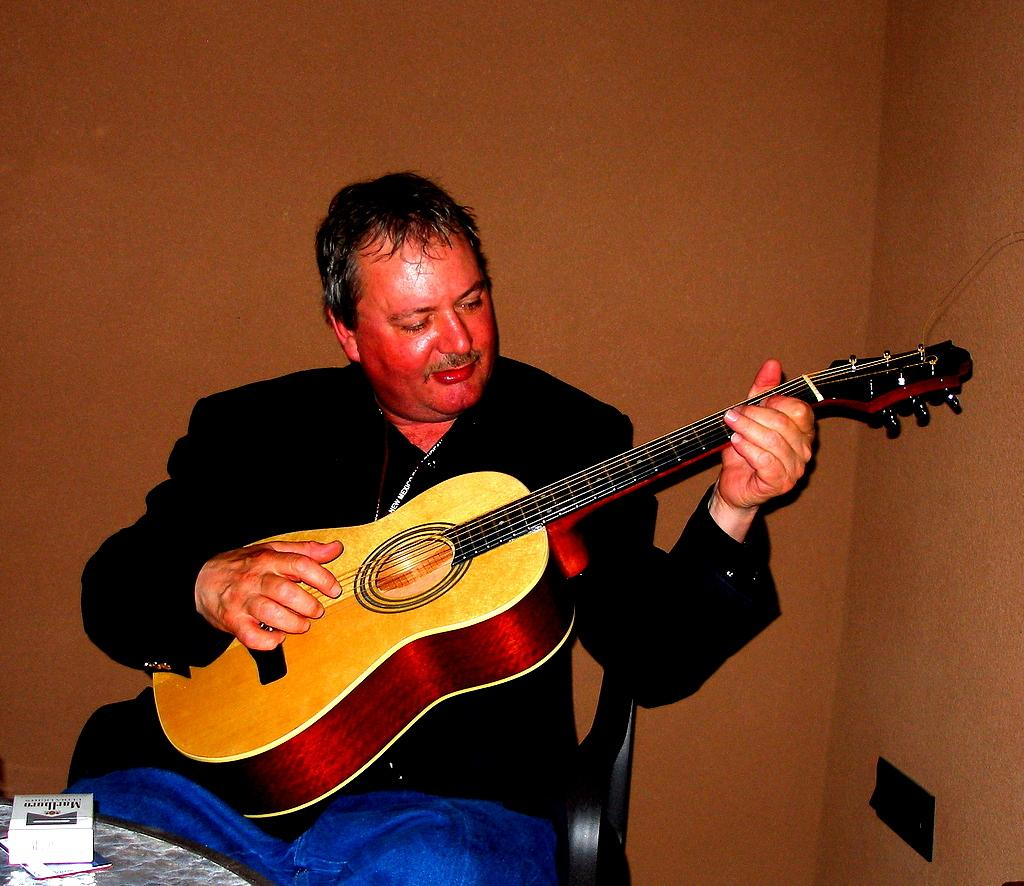What is the person in the image doing? The person is sitting on a chair and holding a guitar. What object is in front of the person? There is a table in front of the person. What is the person wearing? The person is wearing a black jacket. What type of steel is visible in the image? There is no steel present in the image. What boundary is the person sitting near in the image? The image does not show any boundaries or borders. 